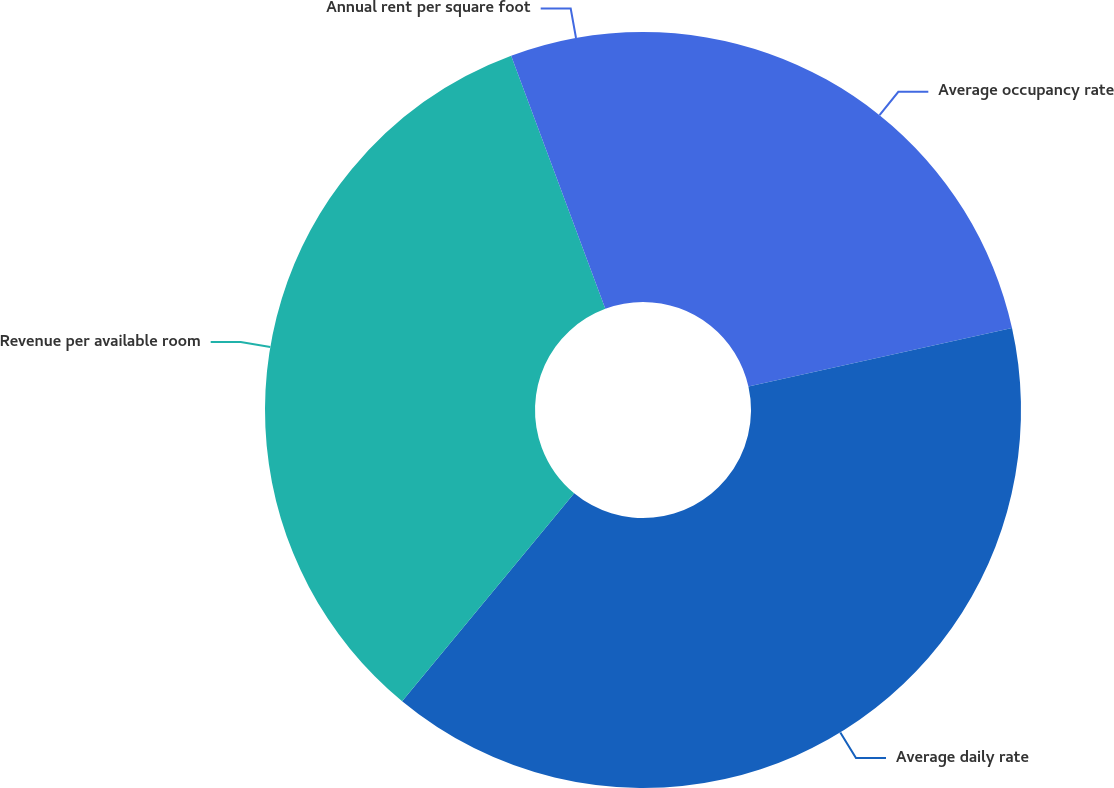<chart> <loc_0><loc_0><loc_500><loc_500><pie_chart><fcel>Average occupancy rate<fcel>Average daily rate<fcel>Revenue per available room<fcel>Annual rent per square foot<nl><fcel>21.52%<fcel>39.47%<fcel>33.33%<fcel>5.67%<nl></chart> 